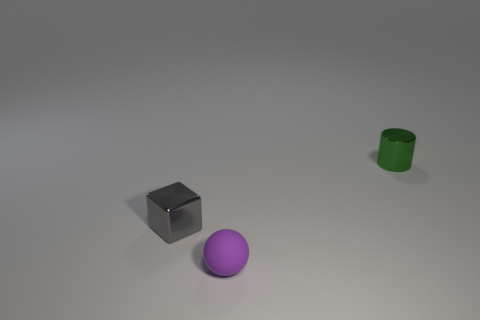The thing that is made of the same material as the tiny green cylinder is what shape?
Your response must be concise. Cube. Are the tiny gray block and the small cylinder made of the same material?
Your response must be concise. Yes. There is a small cylinder that is the same material as the tiny cube; what is its color?
Make the answer very short. Green. There is a gray thing; what shape is it?
Keep it short and to the point. Cube. There is a matte thing that is the same size as the cube; what shape is it?
Keep it short and to the point. Sphere. The small thing that is in front of the block is what color?
Make the answer very short. Purple. Are there any tiny things on the left side of the tiny object behind the small shiny cube?
Provide a short and direct response. Yes. How many things are tiny things that are on the right side of the metal block or small green metal cylinders?
Provide a short and direct response. 2. The tiny object right of the small matte thing in front of the small metal cube is made of what material?
Provide a succinct answer. Metal. Is the number of purple matte objects behind the gray metallic object the same as the number of metallic cylinders to the left of the purple matte ball?
Provide a short and direct response. Yes. 